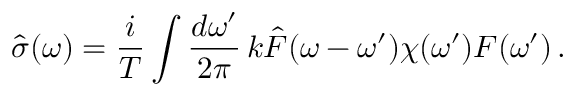Convert formula to latex. <formula><loc_0><loc_0><loc_500><loc_500>\hat { \sigma } ( \omega ) = \frac { i } { T } \int \frac { d \omega ^ { \prime } } { 2 \pi } \, k \hat { F } ( \omega - \omega ^ { \prime } ) \chi ( \omega ^ { \prime } ) F ( \omega ^ { \prime } ) \, .</formula> 